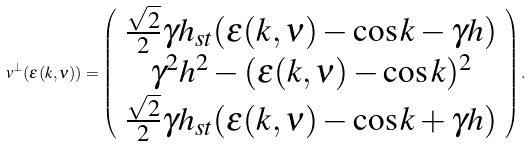Convert formula to latex. <formula><loc_0><loc_0><loc_500><loc_500>v ^ { \bot } ( \varepsilon ( k , \nu ) ) = \left ( \begin{array} { c } \frac { \sqrt { 2 } } { 2 } \gamma h _ { s t } ( \varepsilon ( k , \nu ) - \cos k - \gamma h ) \\ \gamma ^ { 2 } h ^ { 2 } - ( \varepsilon ( k , \nu ) - \cos k ) ^ { 2 } \\ \frac { \sqrt { 2 } } { 2 } \gamma h _ { s t } ( \varepsilon ( k , \nu ) - \cos k + \gamma h ) \end{array} \right ) .</formula> 